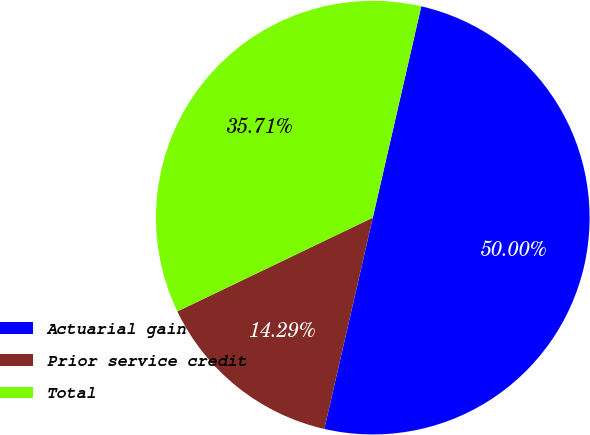<chart> <loc_0><loc_0><loc_500><loc_500><pie_chart><fcel>Actuarial gain<fcel>Prior service credit<fcel>Total<nl><fcel>50.0%<fcel>14.29%<fcel>35.71%<nl></chart> 